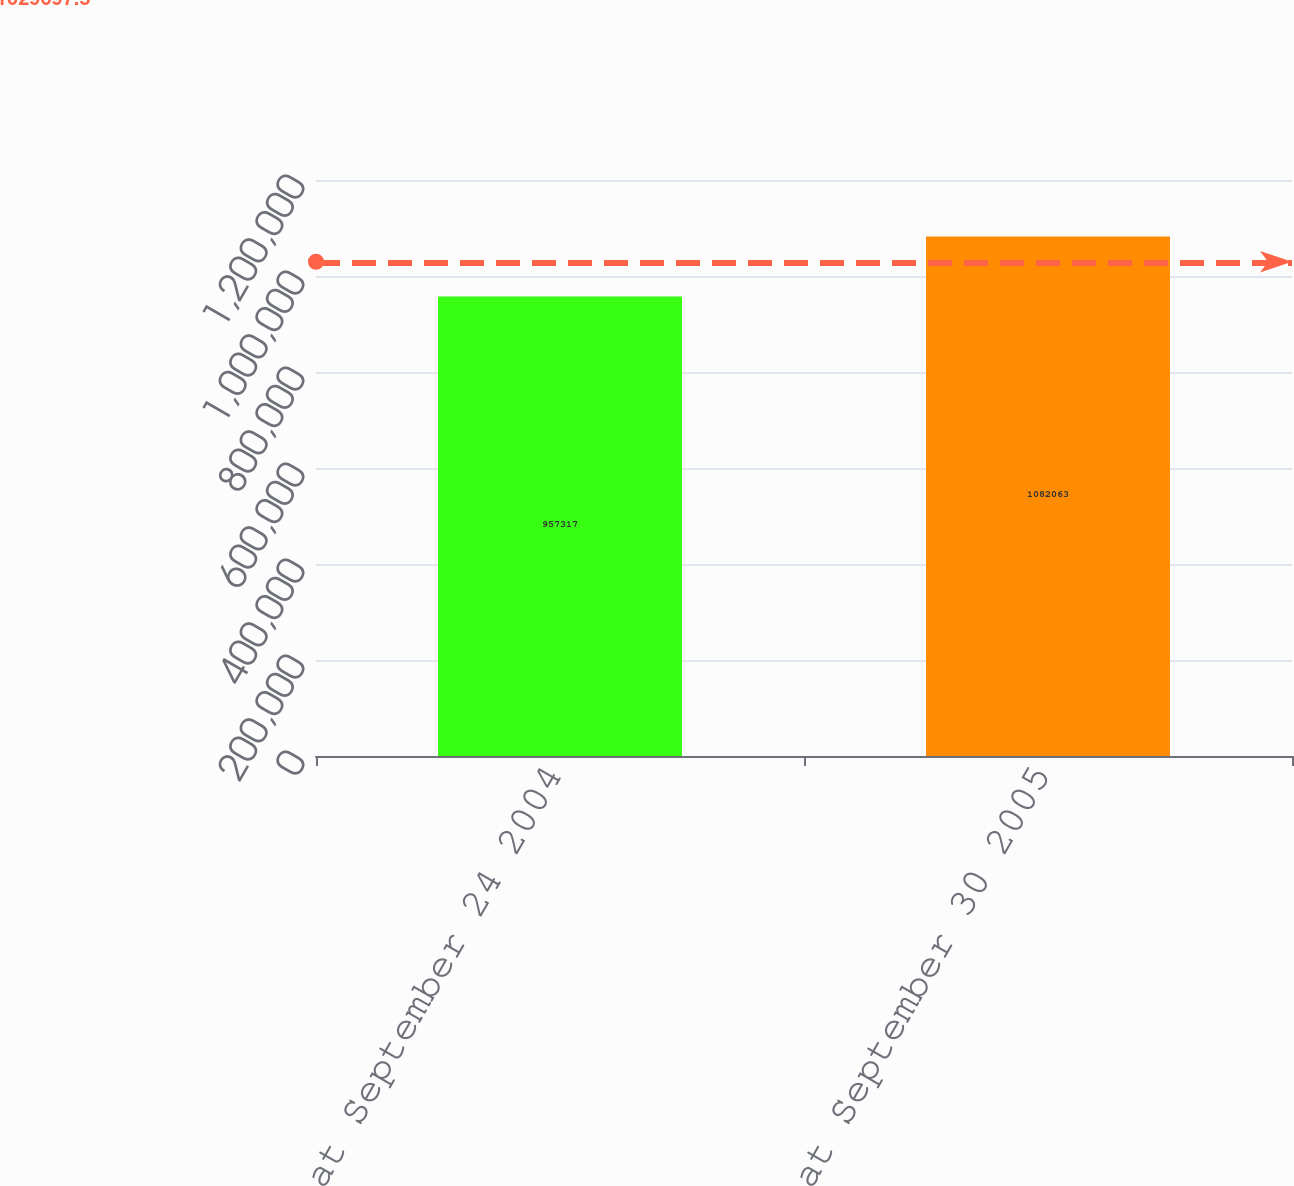Convert chart to OTSL. <chart><loc_0><loc_0><loc_500><loc_500><bar_chart><fcel>Balances at September 24 2004<fcel>Balances at September 30 2005<nl><fcel>957317<fcel>1.08206e+06<nl></chart> 